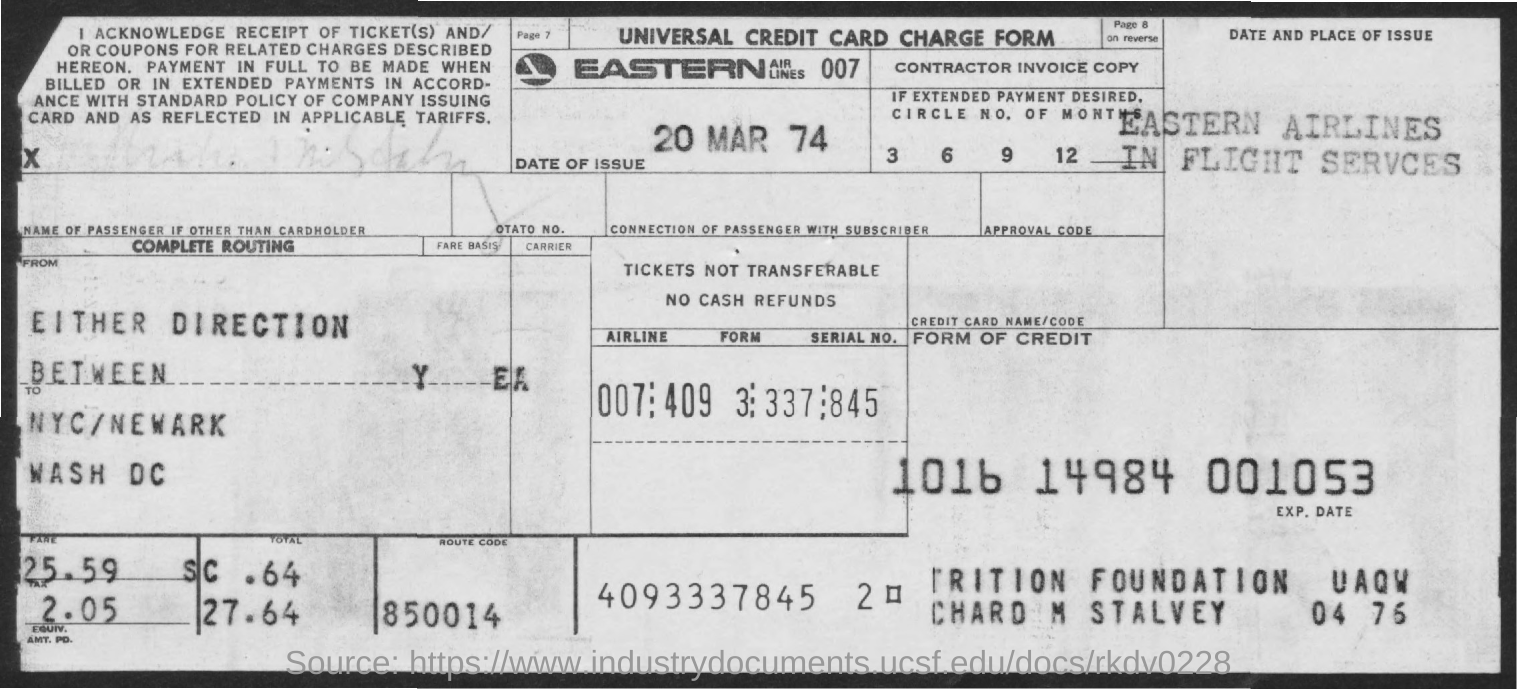What is the date of issue mentioned in the given form ?
Your answer should be compact. 20 MAR 74. What is the route code mentioned in the given form ?
Offer a very short reply. 850014. 